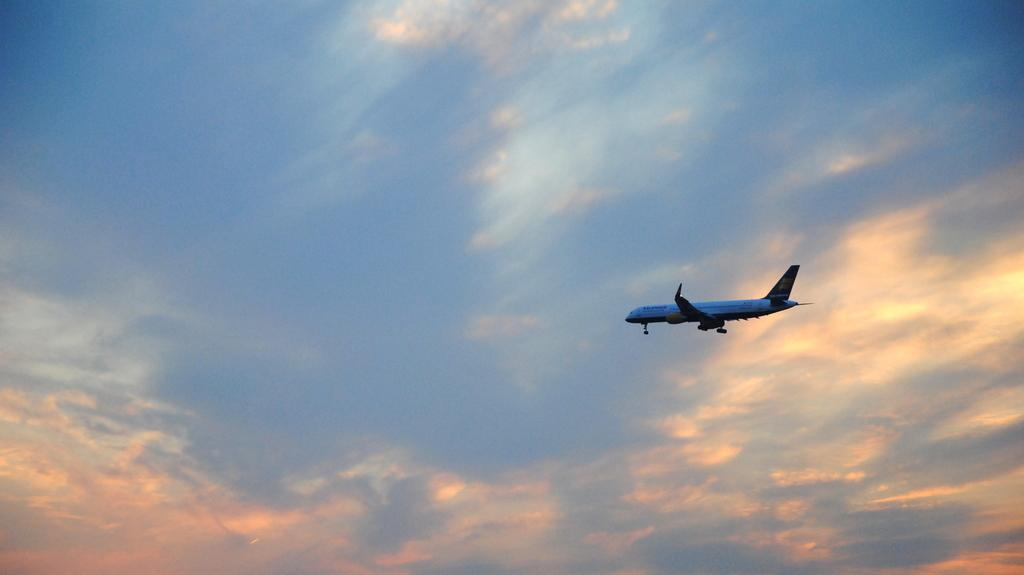What is the main subject of the picture? The main subject of the picture is an airplane. What is the color of the airplane? The airplane is white. What is the airplane doing in the image? The airplane is flying in the sky. What can be seen in the background of the image? The sky is visible in the background of the image. What is the color of the sky? The sky is blue. Are there any additional features in the sky? Yes, clouds are present in the sky. Can you tell me how many glasses are on the hill in the image? There are no glasses or hills present in the image; it features an airplane flying in the sky with a blue background and clouds. 